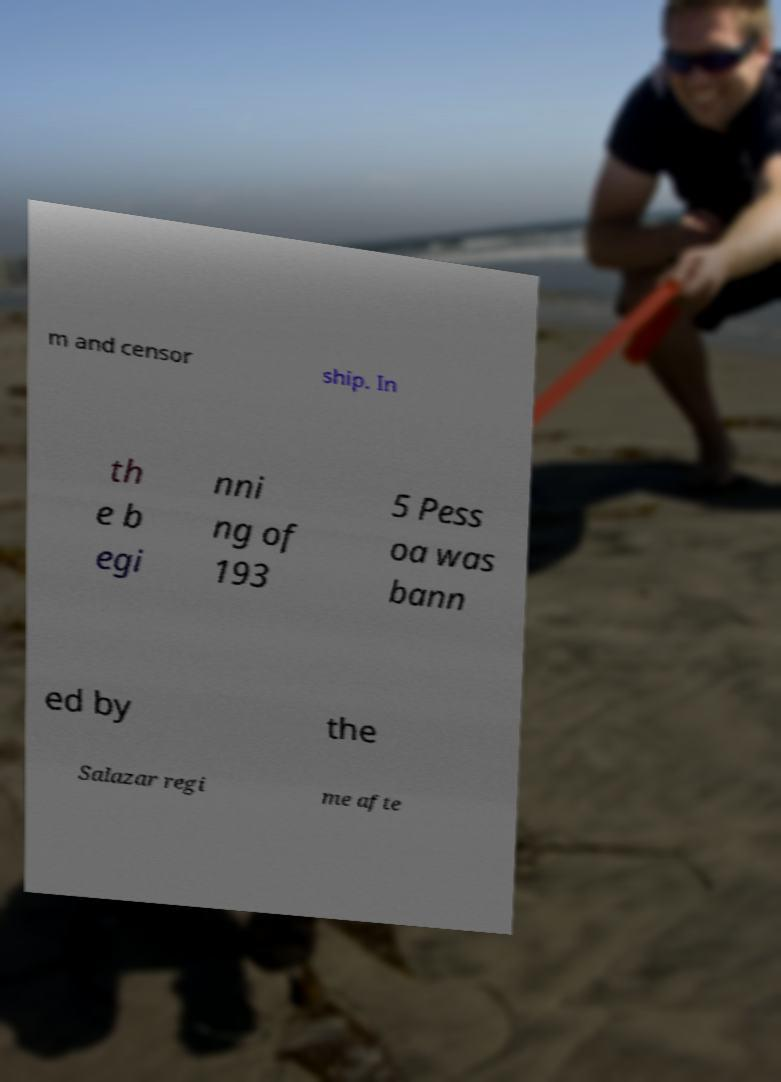Can you accurately transcribe the text from the provided image for me? m and censor ship. In th e b egi nni ng of 193 5 Pess oa was bann ed by the Salazar regi me afte 